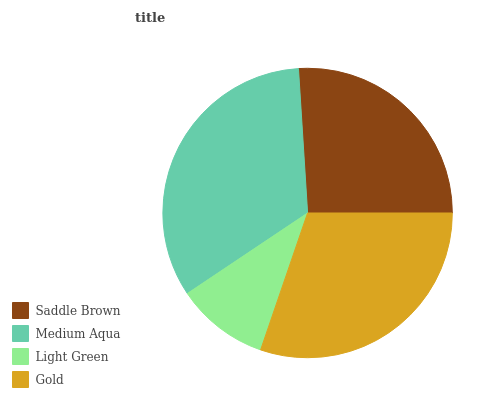Is Light Green the minimum?
Answer yes or no. Yes. Is Medium Aqua the maximum?
Answer yes or no. Yes. Is Medium Aqua the minimum?
Answer yes or no. No. Is Light Green the maximum?
Answer yes or no. No. Is Medium Aqua greater than Light Green?
Answer yes or no. Yes. Is Light Green less than Medium Aqua?
Answer yes or no. Yes. Is Light Green greater than Medium Aqua?
Answer yes or no. No. Is Medium Aqua less than Light Green?
Answer yes or no. No. Is Gold the high median?
Answer yes or no. Yes. Is Saddle Brown the low median?
Answer yes or no. Yes. Is Light Green the high median?
Answer yes or no. No. Is Gold the low median?
Answer yes or no. No. 